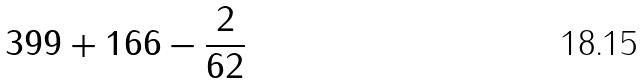<formula> <loc_0><loc_0><loc_500><loc_500>3 9 9 + 1 6 6 - \frac { 2 } { 6 2 }</formula> 